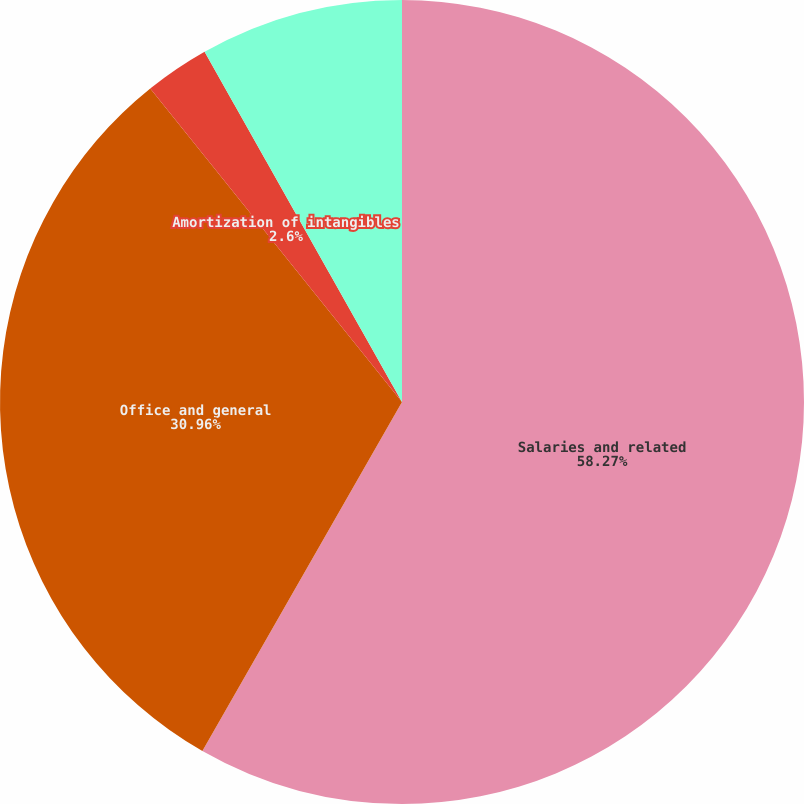Convert chart to OTSL. <chart><loc_0><loc_0><loc_500><loc_500><pie_chart><fcel>Salaries and related<fcel>Office and general<fcel>Amortization of intangibles<fcel>Operating income (loss)<nl><fcel>58.27%<fcel>30.96%<fcel>2.6%<fcel>8.17%<nl></chart> 